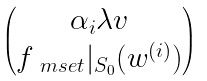<formula> <loc_0><loc_0><loc_500><loc_500>\begin{pmatrix} \alpha _ { i } \lambda v \\ f _ { \ m s e t } | _ { S _ { 0 } } ( w ^ { ( i ) } ) \end{pmatrix}</formula> 